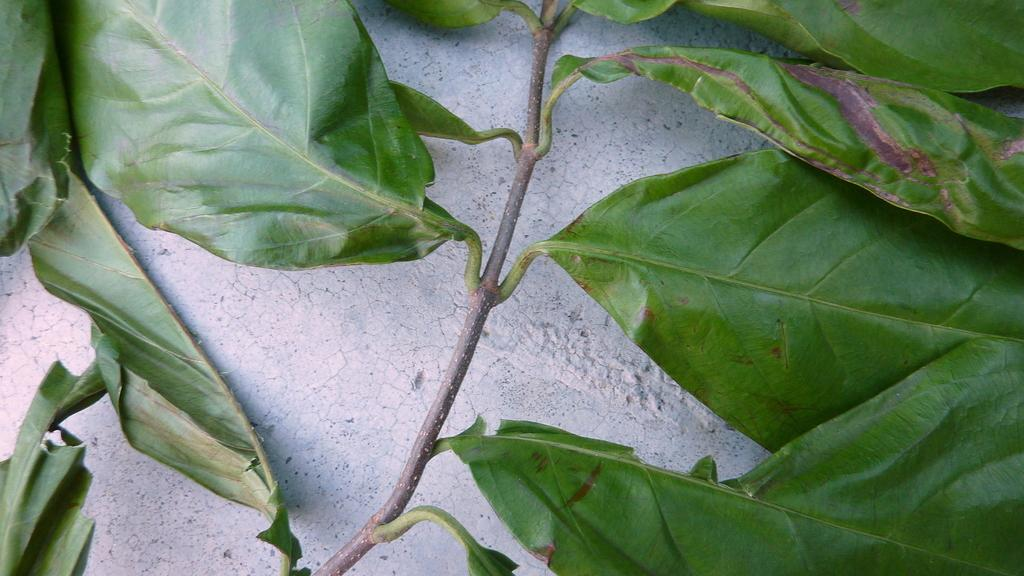What is the main subject of the image? The main subject of the image is a plant. Where is the plant located in the image? The plant is on a white surface. Can you tell me how many times your dad has visited the plant in the image? There is no mention of a dad or any visits in the image, as it only features a plant on a white surface. 